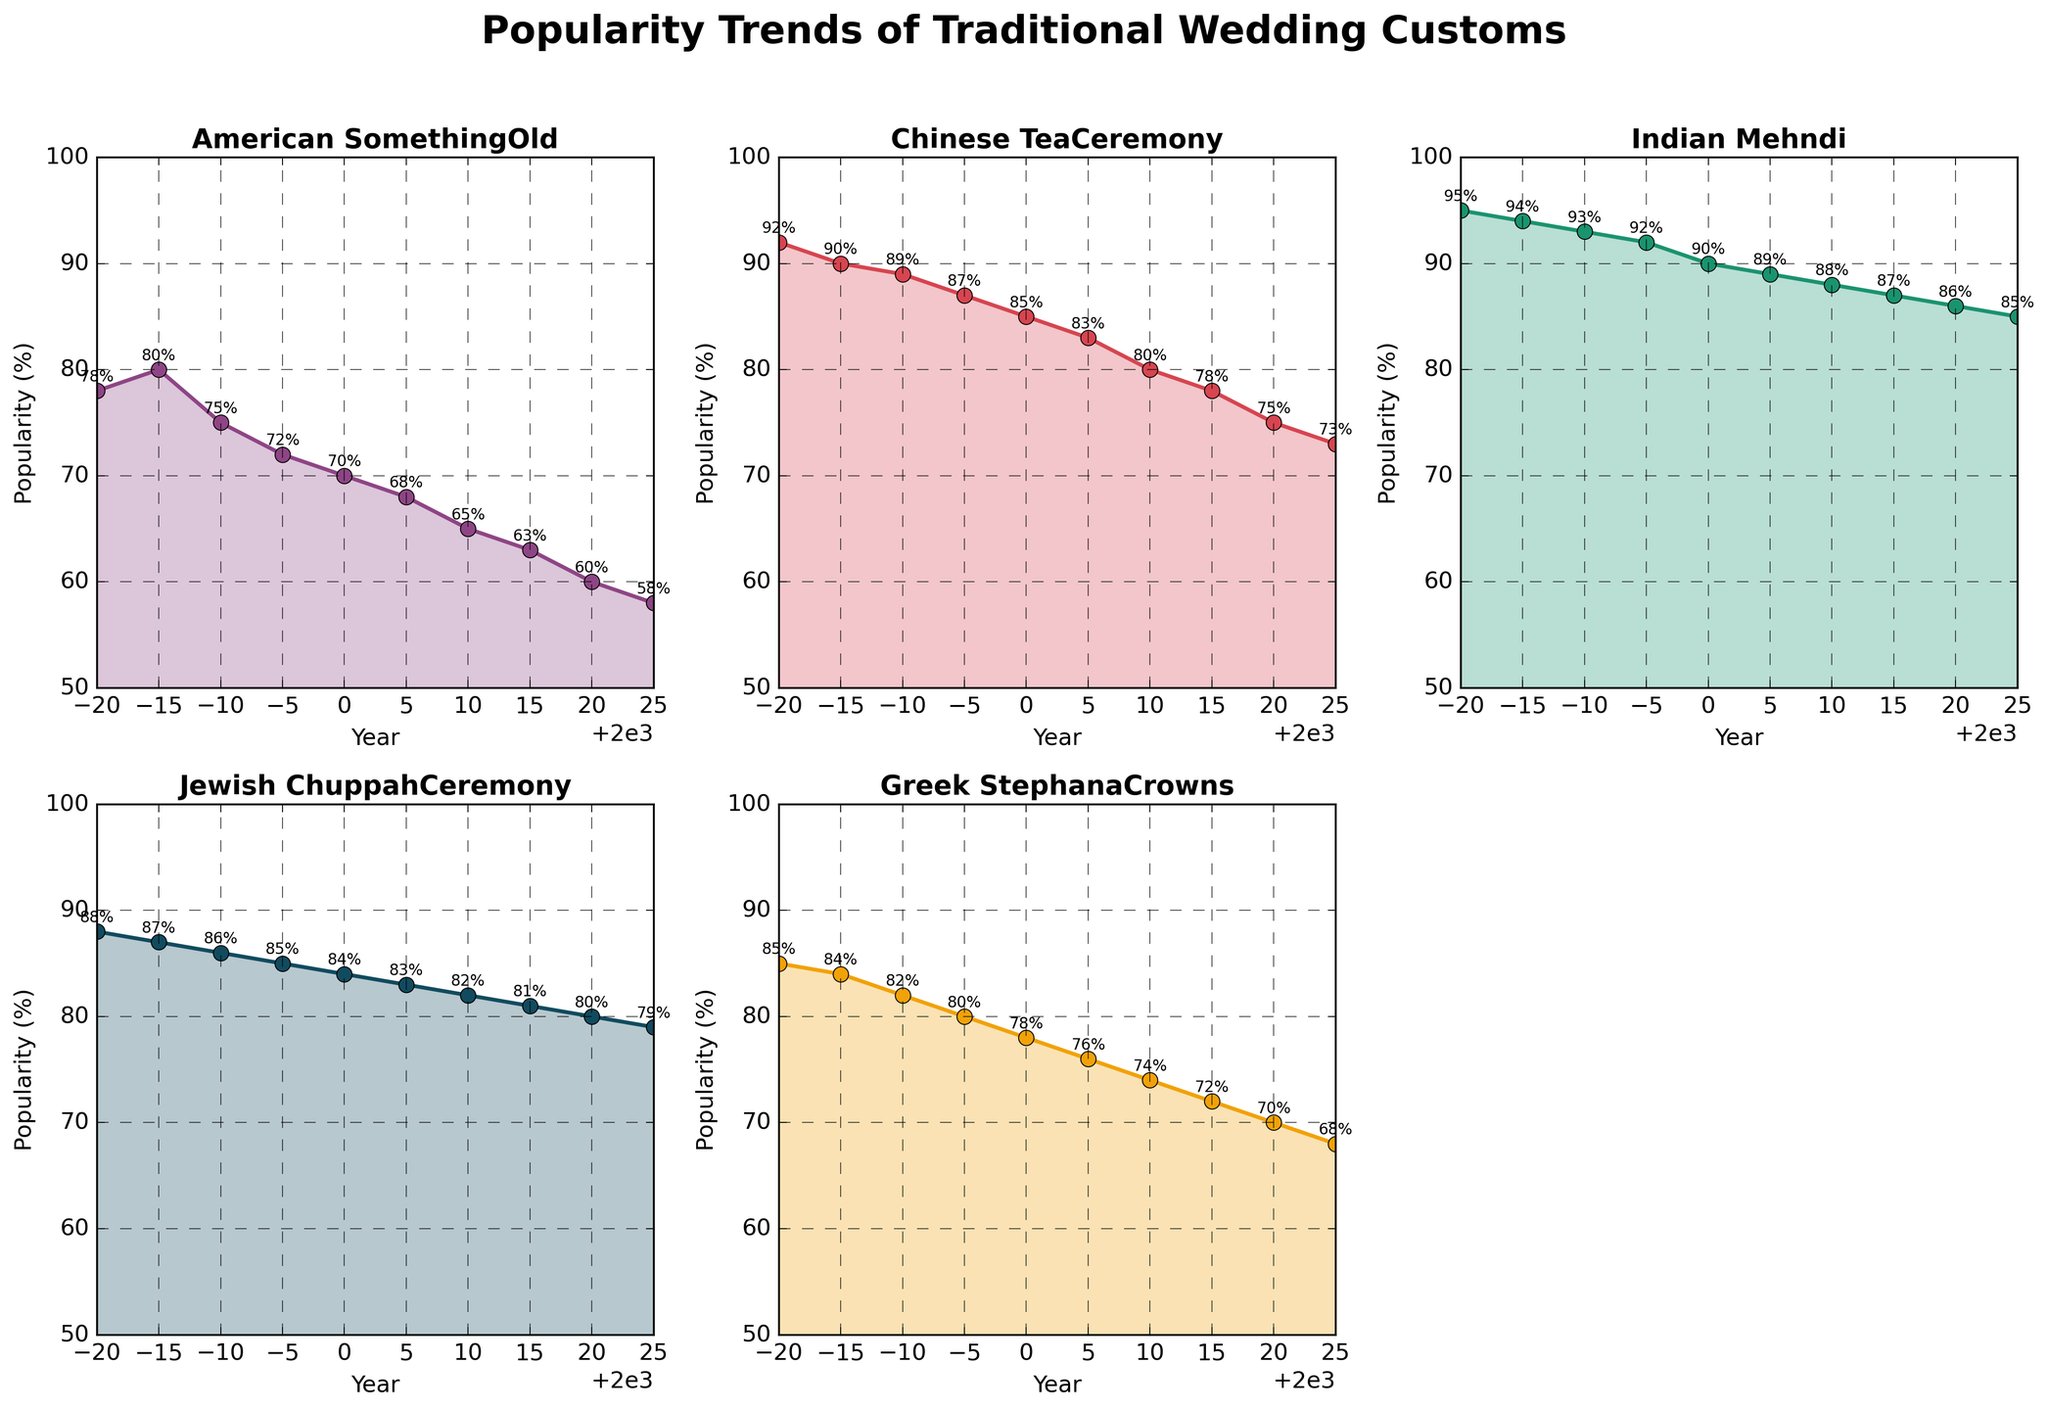What cultural wedding tradition showed the steepest decline in popularity from 1980 to 2025? To find the steepest decline, we need to calculate the difference in popularity from 1980 to 2025 for each tradition. American Something Old declined from 78% to 58% (a 20% drop), Chinese Tea Ceremony from 92% to 73% (a 19% drop), Indian Mehndi from 95% to 85% (a 10% drop), Jewish Chuppah Ceremony from 88% to 79% (a 9% drop), and Greek Stephana Crowns from 85% to 68% (a 17% drop). The greatest decline is 20% for American Something Old.
Answer: American Something Old Which tradition maintains the highest level of popularity consistently from 1980 to 2025? Looking at the plot, Indian Mehndi starts and remains the highest among all traditions, starting at 95% in 1980 and ending at 85% in 2025. None of the other traditions have a higher starting or ending point.
Answer: Indian Mehndi Between 2000 and 2010, which wedding tradition saw the smallest decrease in popularity? Comparing the decrease in popularity between 2000 and 2010: American Something Old goes from 70% to 65% (5% drop), Chinese Tea Ceremony from 85% to 80% (5% drop), Indian Mehndi from 90% to 88% (2% drop), Jewish Chuppah Ceremony from 84% to 82% (2% drop), Greek Stephana Crowns from 78% to 74% (4% drop). The smallest decrease is shared by Indian Mehndi and Jewish Chuppah Ceremony, both at 2%.
Answer: Indian Mehndi and Jewish Chuppah Ceremony Which cultural tradition is experiencing the highest amount of popularity decline in the last decade (2015-2025)? Checking the changes from 2015 to 2025: American Something Old drops from 63% to 58% (5%), Chinese Tea Ceremony from 78% to 73% (5%), Indian Mehndi from 87% to 85% (2%), Jewish Chuppah Ceremony from 81% to 79% (2%), Greek Stephana Crowns from 72% to 68% (4%). The highest declines, both 5%, are in American Something Old and Chinese Tea Ceremony.
Answer: American Something Old and Chinese Tea Ceremony How many wedding traditions have their popularity dropping below 70% by 2025? Assessing the ending popularity for each tradition by 2025, we find: American Something Old (58%), Chinese Tea Ceremony (73%), Indian Mehndi (85%), Jewish Chuppah Ceremony (79%), and Greek Stephana Crowns (68%). American Something Old and Greek Stephana Crowns are below 70%.
Answer: Two Compare the popularity of the Jewish Chuppah Ceremony and Greek Stephana Crowns in 1990. Which one was more popular? Looking at the plot for 1990, the Jewish Chuppah Ceremony had a popularity of 86%, while Greek Stephana Crowns had 82%. Therefore, the Jewish Chuppah Ceremony was more popular.
Answer: Jewish Chuppah Ceremony In what year did American Something Old and Greek Stephana Crowns both hit 85% popularity? By examining the plot, we see that in 1980, both American Something Old and Greek Stephana Crowns were at 85% popularity.
Answer: 1980 What was the average popularity of Chinese Tea Ceremony from 1980 to 2025? To find the average, sum the popularity percentages from each year and divide by the number of years: (92+90+89+87+85+83+80+78+75+73)/10 = 83.2%.
Answer: 83.2% Which two traditions had the closest popularity percentages in 2005? Checking 2005 values: American Something Old (68%), Chinese Tea Ceremony (83%), Indian Mehndi (89%), Jewish Chuppah Ceremony (83%), Greek Stephana Crowns (76%). Chinese Tea Ceremony and Jewish Chuppah Ceremony both had 83%.
Answer: Chinese Tea Ceremony and Jewish Chuppah Ceremony 